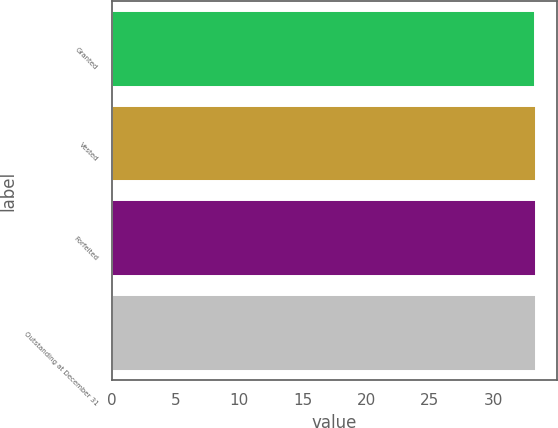Convert chart to OTSL. <chart><loc_0><loc_0><loc_500><loc_500><bar_chart><fcel>Granted<fcel>Vested<fcel>Forfeited<fcel>Outstanding at December 31<nl><fcel>33.27<fcel>33.3<fcel>33.3<fcel>33.32<nl></chart> 